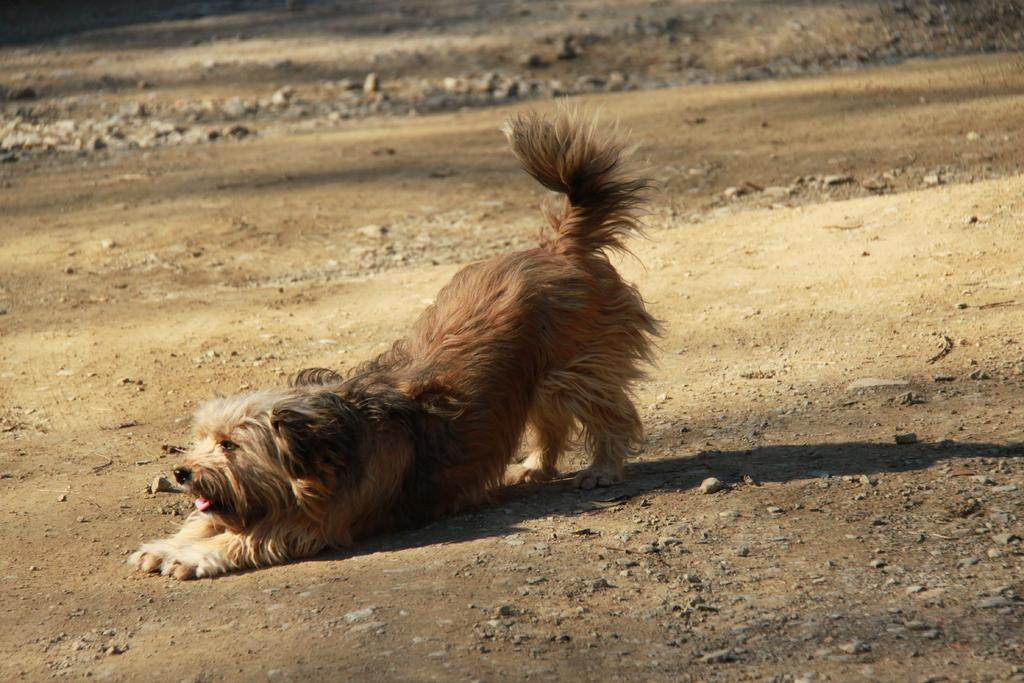What is the main subject in the center of the image? There is a dog in the center of the image. What else can be seen in the image besides the dog? There are stones in the image. What type of fowl is depicted in the caption of the image? There is no caption present in the image, and therefore no fowl can be identified from it. 